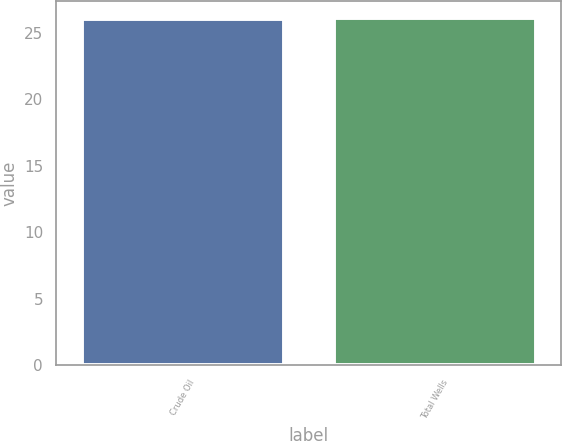Convert chart to OTSL. <chart><loc_0><loc_0><loc_500><loc_500><bar_chart><fcel>Crude Oil<fcel>Total Wells<nl><fcel>26<fcel>26.1<nl></chart> 